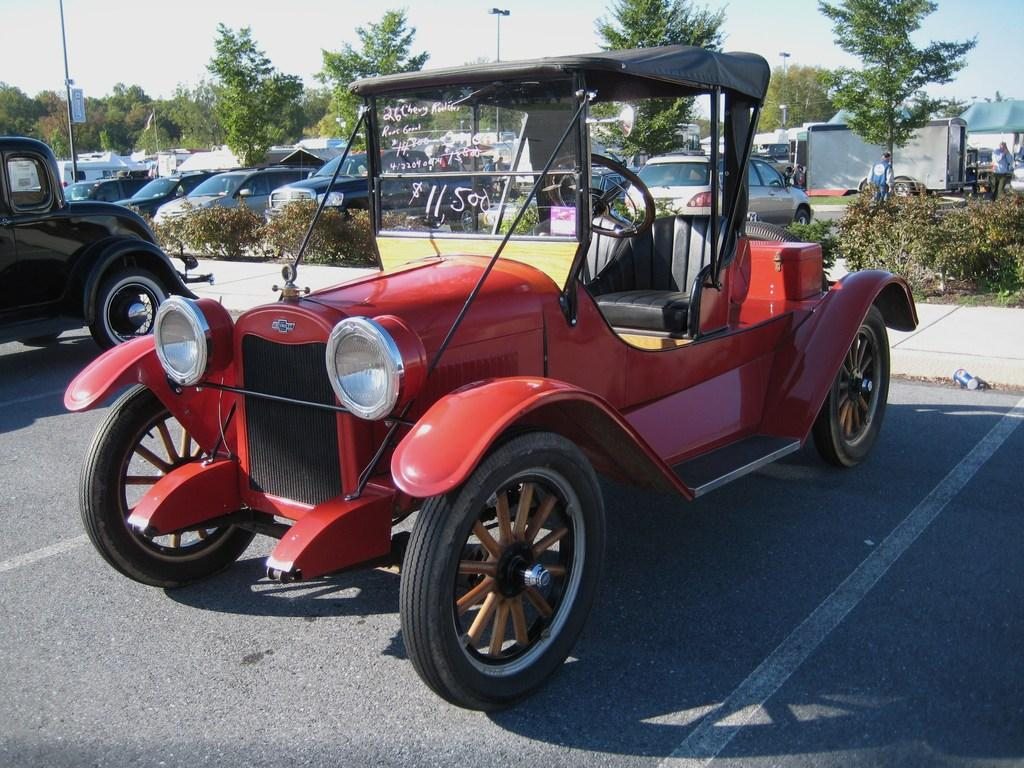What type of vehicle is in the image? There is a red color jeep in the image. What can be seen on the glass of the jeep? Something is written on the glass of the jeep. What else is visible in the back of the image? There are many vehicles and plants in the back of the image. What type of vegetation is present in the back of the image? There are trees in the back of the image. What is visible in the background of the image? The sky is visible in the background of the image. How many pigs are visible in the image? There are no pigs present in the image. What company is responsible for the vehicles in the image? The image does not provide information about the company responsible for the vehicles. 